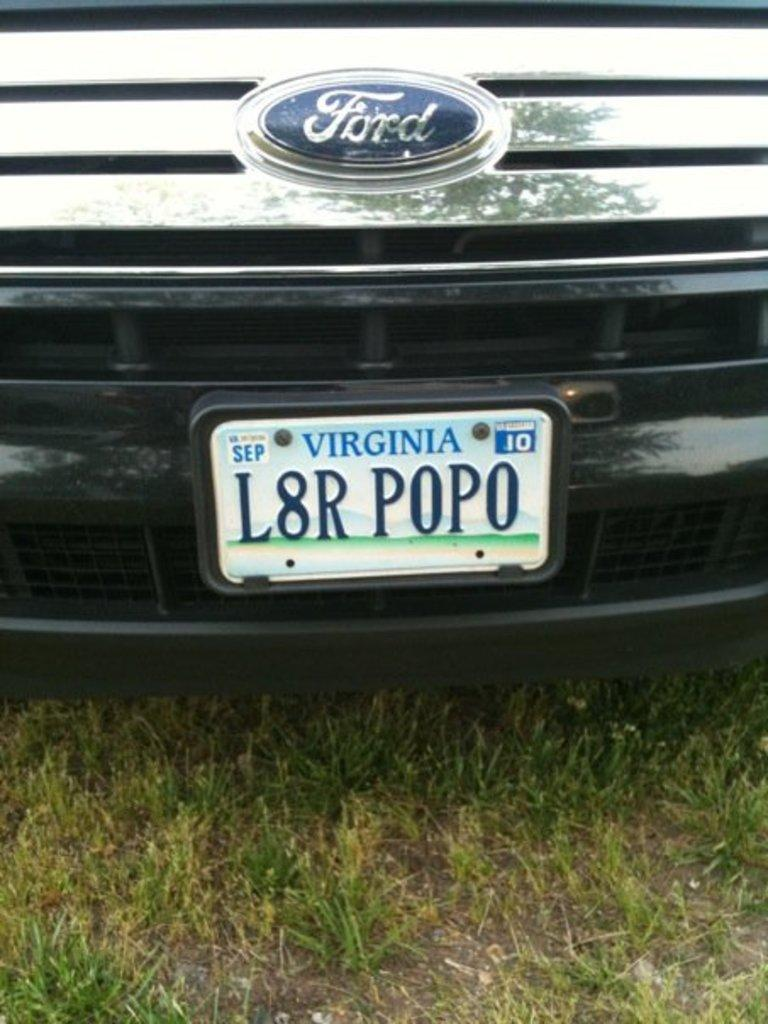<image>
Present a compact description of the photo's key features. A ford with a Virgina tag that reads L8R POPO. 